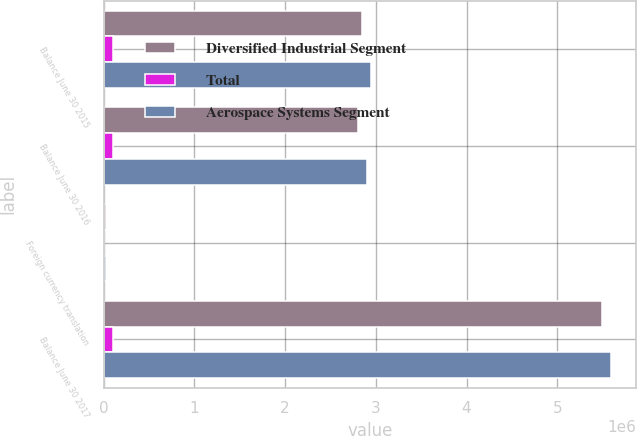Convert chart to OTSL. <chart><loc_0><loc_0><loc_500><loc_500><stacked_bar_chart><ecel><fcel>Balance June 30 2015<fcel>Balance June 30 2016<fcel>Foreign currency translation<fcel>Balance June 30 2017<nl><fcel>Diversified Industrial Segment<fcel>2.84404e+06<fcel>2.8044e+06<fcel>28962<fcel>5.48824e+06<nl><fcel>Total<fcel>98634<fcel>98634<fcel>8<fcel>98642<nl><fcel>Aerospace Systems Segment<fcel>2.94268e+06<fcel>2.90304e+06<fcel>28970<fcel>5.58688e+06<nl></chart> 